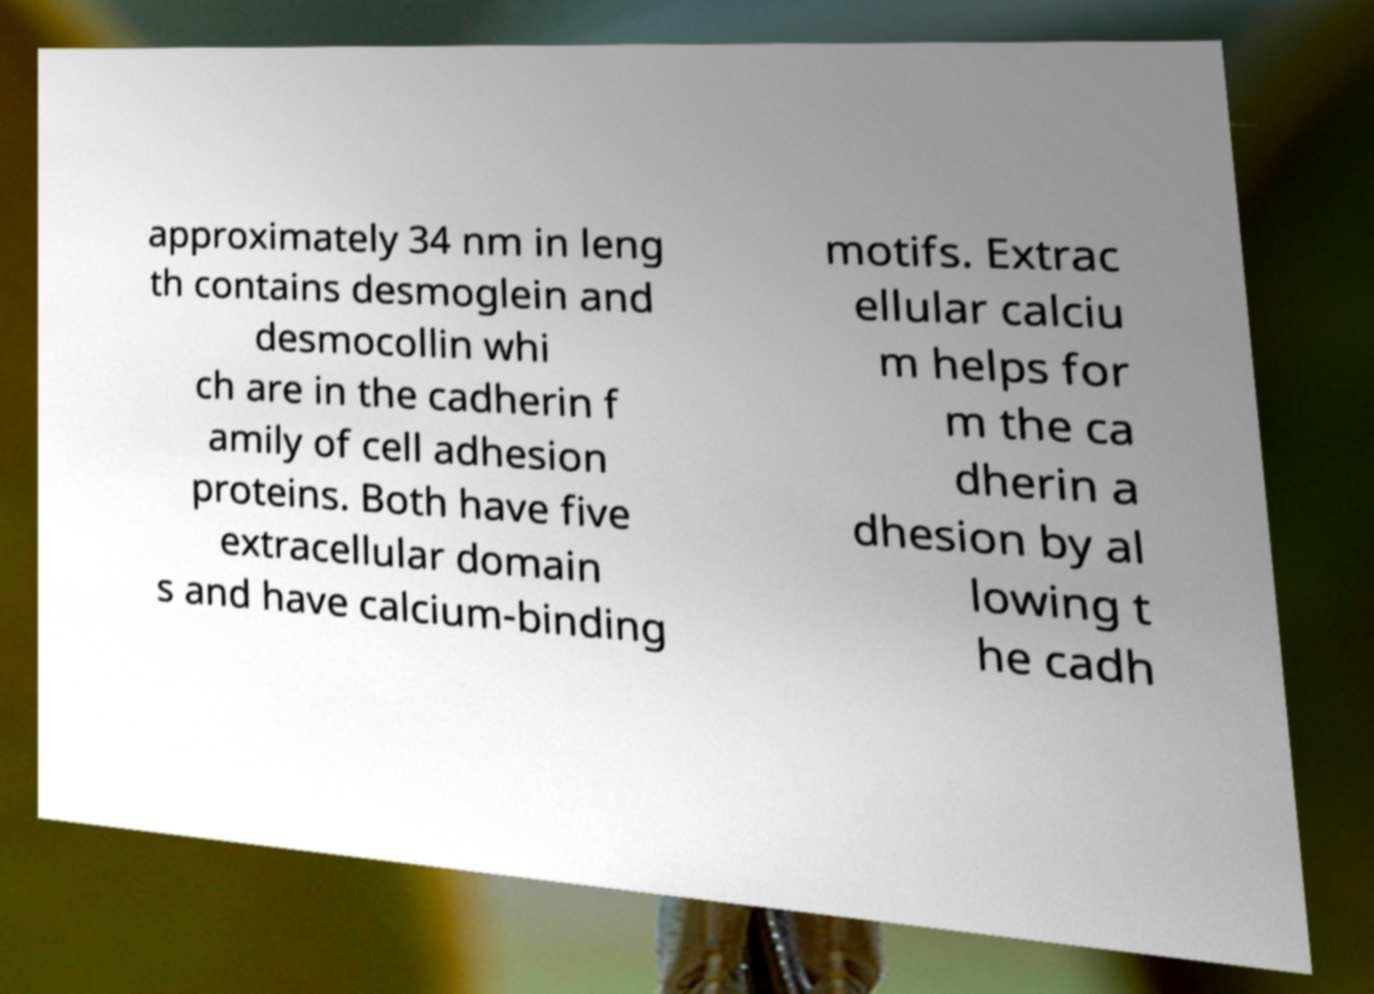What messages or text are displayed in this image? I need them in a readable, typed format. approximately 34 nm in leng th contains desmoglein and desmocollin whi ch are in the cadherin f amily of cell adhesion proteins. Both have five extracellular domain s and have calcium-binding motifs. Extrac ellular calciu m helps for m the ca dherin a dhesion by al lowing t he cadh 